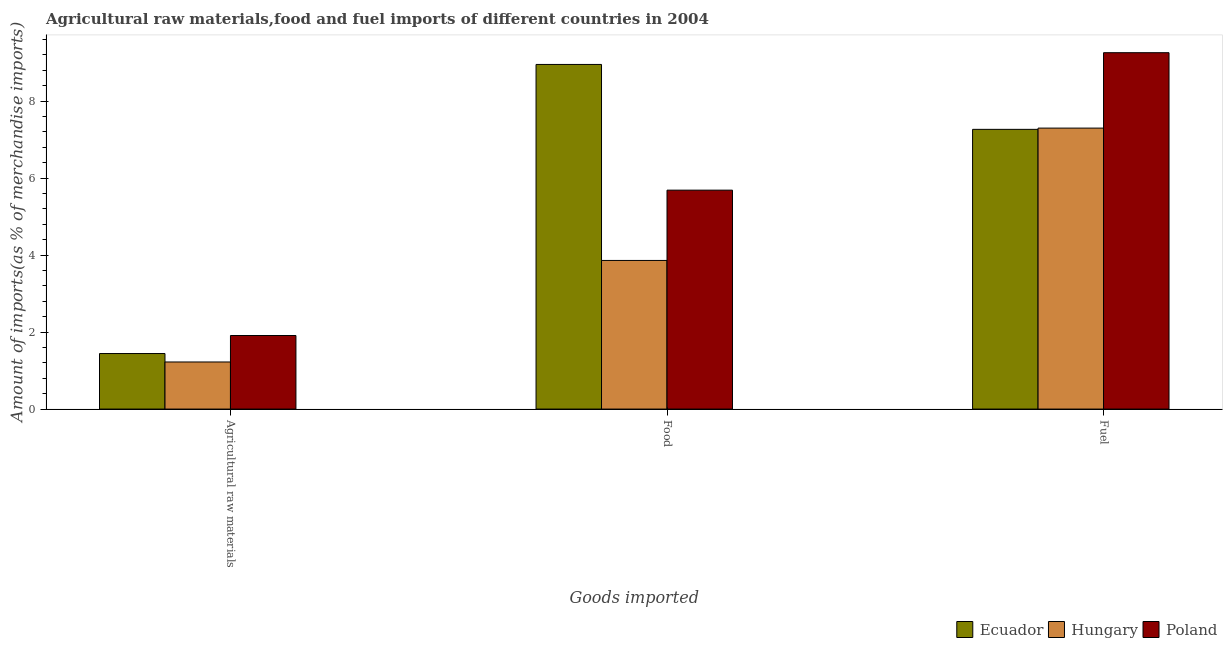How many groups of bars are there?
Keep it short and to the point. 3. Are the number of bars per tick equal to the number of legend labels?
Your response must be concise. Yes. What is the label of the 2nd group of bars from the left?
Your answer should be very brief. Food. What is the percentage of fuel imports in Hungary?
Your response must be concise. 7.3. Across all countries, what is the maximum percentage of fuel imports?
Provide a succinct answer. 9.26. Across all countries, what is the minimum percentage of food imports?
Provide a short and direct response. 3.86. In which country was the percentage of raw materials imports maximum?
Offer a terse response. Poland. In which country was the percentage of raw materials imports minimum?
Provide a short and direct response. Hungary. What is the total percentage of fuel imports in the graph?
Make the answer very short. 23.82. What is the difference between the percentage of fuel imports in Hungary and that in Ecuador?
Your answer should be very brief. 0.03. What is the difference between the percentage of fuel imports in Hungary and the percentage of food imports in Ecuador?
Provide a short and direct response. -1.65. What is the average percentage of food imports per country?
Your response must be concise. 6.17. What is the difference between the percentage of raw materials imports and percentage of food imports in Hungary?
Your answer should be very brief. -2.64. In how many countries, is the percentage of raw materials imports greater than 4 %?
Offer a very short reply. 0. What is the ratio of the percentage of fuel imports in Hungary to that in Poland?
Your answer should be compact. 0.79. Is the percentage of fuel imports in Hungary less than that in Ecuador?
Give a very brief answer. No. Is the difference between the percentage of raw materials imports in Poland and Hungary greater than the difference between the percentage of fuel imports in Poland and Hungary?
Make the answer very short. No. What is the difference between the highest and the second highest percentage of food imports?
Your response must be concise. 3.27. What is the difference between the highest and the lowest percentage of fuel imports?
Keep it short and to the point. 1.99. In how many countries, is the percentage of fuel imports greater than the average percentage of fuel imports taken over all countries?
Ensure brevity in your answer.  1. What does the 1st bar from the left in Food represents?
Ensure brevity in your answer.  Ecuador. What does the 2nd bar from the right in Fuel represents?
Provide a short and direct response. Hungary. How many bars are there?
Provide a succinct answer. 9. Are all the bars in the graph horizontal?
Provide a short and direct response. No. How many countries are there in the graph?
Keep it short and to the point. 3. Does the graph contain any zero values?
Provide a succinct answer. No. Does the graph contain grids?
Provide a short and direct response. No. How many legend labels are there?
Make the answer very short. 3. What is the title of the graph?
Provide a short and direct response. Agricultural raw materials,food and fuel imports of different countries in 2004. Does "Syrian Arab Republic" appear as one of the legend labels in the graph?
Your answer should be very brief. No. What is the label or title of the X-axis?
Provide a short and direct response. Goods imported. What is the label or title of the Y-axis?
Give a very brief answer. Amount of imports(as % of merchandise imports). What is the Amount of imports(as % of merchandise imports) of Ecuador in Agricultural raw materials?
Give a very brief answer. 1.44. What is the Amount of imports(as % of merchandise imports) in Hungary in Agricultural raw materials?
Provide a succinct answer. 1.22. What is the Amount of imports(as % of merchandise imports) in Poland in Agricultural raw materials?
Your answer should be very brief. 1.91. What is the Amount of imports(as % of merchandise imports) of Ecuador in Food?
Ensure brevity in your answer.  8.95. What is the Amount of imports(as % of merchandise imports) in Hungary in Food?
Ensure brevity in your answer.  3.86. What is the Amount of imports(as % of merchandise imports) of Poland in Food?
Keep it short and to the point. 5.69. What is the Amount of imports(as % of merchandise imports) of Ecuador in Fuel?
Offer a very short reply. 7.27. What is the Amount of imports(as % of merchandise imports) of Hungary in Fuel?
Your answer should be very brief. 7.3. What is the Amount of imports(as % of merchandise imports) of Poland in Fuel?
Ensure brevity in your answer.  9.26. Across all Goods imported, what is the maximum Amount of imports(as % of merchandise imports) in Ecuador?
Give a very brief answer. 8.95. Across all Goods imported, what is the maximum Amount of imports(as % of merchandise imports) of Hungary?
Your response must be concise. 7.3. Across all Goods imported, what is the maximum Amount of imports(as % of merchandise imports) of Poland?
Make the answer very short. 9.26. Across all Goods imported, what is the minimum Amount of imports(as % of merchandise imports) in Ecuador?
Offer a very short reply. 1.44. Across all Goods imported, what is the minimum Amount of imports(as % of merchandise imports) of Hungary?
Offer a terse response. 1.22. Across all Goods imported, what is the minimum Amount of imports(as % of merchandise imports) of Poland?
Your response must be concise. 1.91. What is the total Amount of imports(as % of merchandise imports) in Ecuador in the graph?
Make the answer very short. 17.66. What is the total Amount of imports(as % of merchandise imports) in Hungary in the graph?
Provide a short and direct response. 12.38. What is the total Amount of imports(as % of merchandise imports) of Poland in the graph?
Ensure brevity in your answer.  16.86. What is the difference between the Amount of imports(as % of merchandise imports) in Ecuador in Agricultural raw materials and that in Food?
Ensure brevity in your answer.  -7.51. What is the difference between the Amount of imports(as % of merchandise imports) in Hungary in Agricultural raw materials and that in Food?
Provide a succinct answer. -2.64. What is the difference between the Amount of imports(as % of merchandise imports) in Poland in Agricultural raw materials and that in Food?
Provide a short and direct response. -3.78. What is the difference between the Amount of imports(as % of merchandise imports) of Ecuador in Agricultural raw materials and that in Fuel?
Provide a short and direct response. -5.82. What is the difference between the Amount of imports(as % of merchandise imports) in Hungary in Agricultural raw materials and that in Fuel?
Provide a succinct answer. -6.08. What is the difference between the Amount of imports(as % of merchandise imports) of Poland in Agricultural raw materials and that in Fuel?
Offer a terse response. -7.35. What is the difference between the Amount of imports(as % of merchandise imports) of Ecuador in Food and that in Fuel?
Offer a very short reply. 1.69. What is the difference between the Amount of imports(as % of merchandise imports) of Hungary in Food and that in Fuel?
Keep it short and to the point. -3.44. What is the difference between the Amount of imports(as % of merchandise imports) in Poland in Food and that in Fuel?
Ensure brevity in your answer.  -3.57. What is the difference between the Amount of imports(as % of merchandise imports) in Ecuador in Agricultural raw materials and the Amount of imports(as % of merchandise imports) in Hungary in Food?
Ensure brevity in your answer.  -2.42. What is the difference between the Amount of imports(as % of merchandise imports) in Ecuador in Agricultural raw materials and the Amount of imports(as % of merchandise imports) in Poland in Food?
Give a very brief answer. -4.24. What is the difference between the Amount of imports(as % of merchandise imports) in Hungary in Agricultural raw materials and the Amount of imports(as % of merchandise imports) in Poland in Food?
Ensure brevity in your answer.  -4.46. What is the difference between the Amount of imports(as % of merchandise imports) in Ecuador in Agricultural raw materials and the Amount of imports(as % of merchandise imports) in Hungary in Fuel?
Offer a terse response. -5.86. What is the difference between the Amount of imports(as % of merchandise imports) in Ecuador in Agricultural raw materials and the Amount of imports(as % of merchandise imports) in Poland in Fuel?
Provide a succinct answer. -7.82. What is the difference between the Amount of imports(as % of merchandise imports) of Hungary in Agricultural raw materials and the Amount of imports(as % of merchandise imports) of Poland in Fuel?
Your answer should be very brief. -8.03. What is the difference between the Amount of imports(as % of merchandise imports) of Ecuador in Food and the Amount of imports(as % of merchandise imports) of Hungary in Fuel?
Make the answer very short. 1.65. What is the difference between the Amount of imports(as % of merchandise imports) in Ecuador in Food and the Amount of imports(as % of merchandise imports) in Poland in Fuel?
Provide a short and direct response. -0.31. What is the difference between the Amount of imports(as % of merchandise imports) of Hungary in Food and the Amount of imports(as % of merchandise imports) of Poland in Fuel?
Your answer should be very brief. -5.4. What is the average Amount of imports(as % of merchandise imports) in Ecuador per Goods imported?
Provide a succinct answer. 5.89. What is the average Amount of imports(as % of merchandise imports) of Hungary per Goods imported?
Provide a short and direct response. 4.13. What is the average Amount of imports(as % of merchandise imports) in Poland per Goods imported?
Offer a very short reply. 5.62. What is the difference between the Amount of imports(as % of merchandise imports) in Ecuador and Amount of imports(as % of merchandise imports) in Hungary in Agricultural raw materials?
Offer a terse response. 0.22. What is the difference between the Amount of imports(as % of merchandise imports) in Ecuador and Amount of imports(as % of merchandise imports) in Poland in Agricultural raw materials?
Provide a short and direct response. -0.47. What is the difference between the Amount of imports(as % of merchandise imports) of Hungary and Amount of imports(as % of merchandise imports) of Poland in Agricultural raw materials?
Make the answer very short. -0.69. What is the difference between the Amount of imports(as % of merchandise imports) of Ecuador and Amount of imports(as % of merchandise imports) of Hungary in Food?
Offer a terse response. 5.09. What is the difference between the Amount of imports(as % of merchandise imports) in Ecuador and Amount of imports(as % of merchandise imports) in Poland in Food?
Your response must be concise. 3.27. What is the difference between the Amount of imports(as % of merchandise imports) of Hungary and Amount of imports(as % of merchandise imports) of Poland in Food?
Keep it short and to the point. -1.83. What is the difference between the Amount of imports(as % of merchandise imports) of Ecuador and Amount of imports(as % of merchandise imports) of Hungary in Fuel?
Your response must be concise. -0.03. What is the difference between the Amount of imports(as % of merchandise imports) of Ecuador and Amount of imports(as % of merchandise imports) of Poland in Fuel?
Provide a short and direct response. -1.99. What is the difference between the Amount of imports(as % of merchandise imports) in Hungary and Amount of imports(as % of merchandise imports) in Poland in Fuel?
Offer a terse response. -1.96. What is the ratio of the Amount of imports(as % of merchandise imports) in Ecuador in Agricultural raw materials to that in Food?
Give a very brief answer. 0.16. What is the ratio of the Amount of imports(as % of merchandise imports) of Hungary in Agricultural raw materials to that in Food?
Keep it short and to the point. 0.32. What is the ratio of the Amount of imports(as % of merchandise imports) of Poland in Agricultural raw materials to that in Food?
Give a very brief answer. 0.34. What is the ratio of the Amount of imports(as % of merchandise imports) in Ecuador in Agricultural raw materials to that in Fuel?
Give a very brief answer. 0.2. What is the ratio of the Amount of imports(as % of merchandise imports) in Hungary in Agricultural raw materials to that in Fuel?
Make the answer very short. 0.17. What is the ratio of the Amount of imports(as % of merchandise imports) of Poland in Agricultural raw materials to that in Fuel?
Ensure brevity in your answer.  0.21. What is the ratio of the Amount of imports(as % of merchandise imports) of Ecuador in Food to that in Fuel?
Provide a short and direct response. 1.23. What is the ratio of the Amount of imports(as % of merchandise imports) in Hungary in Food to that in Fuel?
Ensure brevity in your answer.  0.53. What is the ratio of the Amount of imports(as % of merchandise imports) of Poland in Food to that in Fuel?
Give a very brief answer. 0.61. What is the difference between the highest and the second highest Amount of imports(as % of merchandise imports) in Ecuador?
Ensure brevity in your answer.  1.69. What is the difference between the highest and the second highest Amount of imports(as % of merchandise imports) of Hungary?
Offer a very short reply. 3.44. What is the difference between the highest and the second highest Amount of imports(as % of merchandise imports) in Poland?
Your answer should be very brief. 3.57. What is the difference between the highest and the lowest Amount of imports(as % of merchandise imports) of Ecuador?
Ensure brevity in your answer.  7.51. What is the difference between the highest and the lowest Amount of imports(as % of merchandise imports) of Hungary?
Ensure brevity in your answer.  6.08. What is the difference between the highest and the lowest Amount of imports(as % of merchandise imports) of Poland?
Make the answer very short. 7.35. 